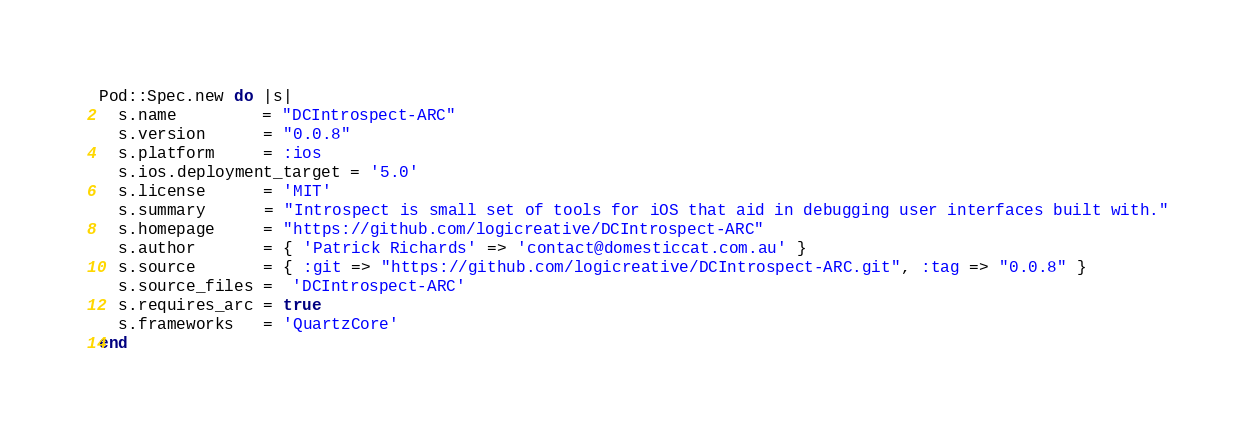Convert code to text. <code><loc_0><loc_0><loc_500><loc_500><_Ruby_>Pod::Spec.new do |s|
  s.name         = "DCIntrospect-ARC"
  s.version      = "0.0.8"
  s.platform 	 = :ios
  s.ios.deployment_target = '5.0'
  s.license      = 'MIT'
  s.summary      = "Introspect is small set of tools for iOS that aid in debugging user interfaces built with."
  s.homepage     = "https://github.com/logicreative/DCIntrospect-ARC"
  s.author       = { 'Patrick Richards' => 'contact@domesticcat.com.au' }
  s.source       = { :git => "https://github.com/logicreative/DCIntrospect-ARC.git", :tag => "0.0.8" }
  s.source_files =  'DCIntrospect-ARC'
  s.requires_arc = true
  s.frameworks   = 'QuartzCore'
end
</code> 